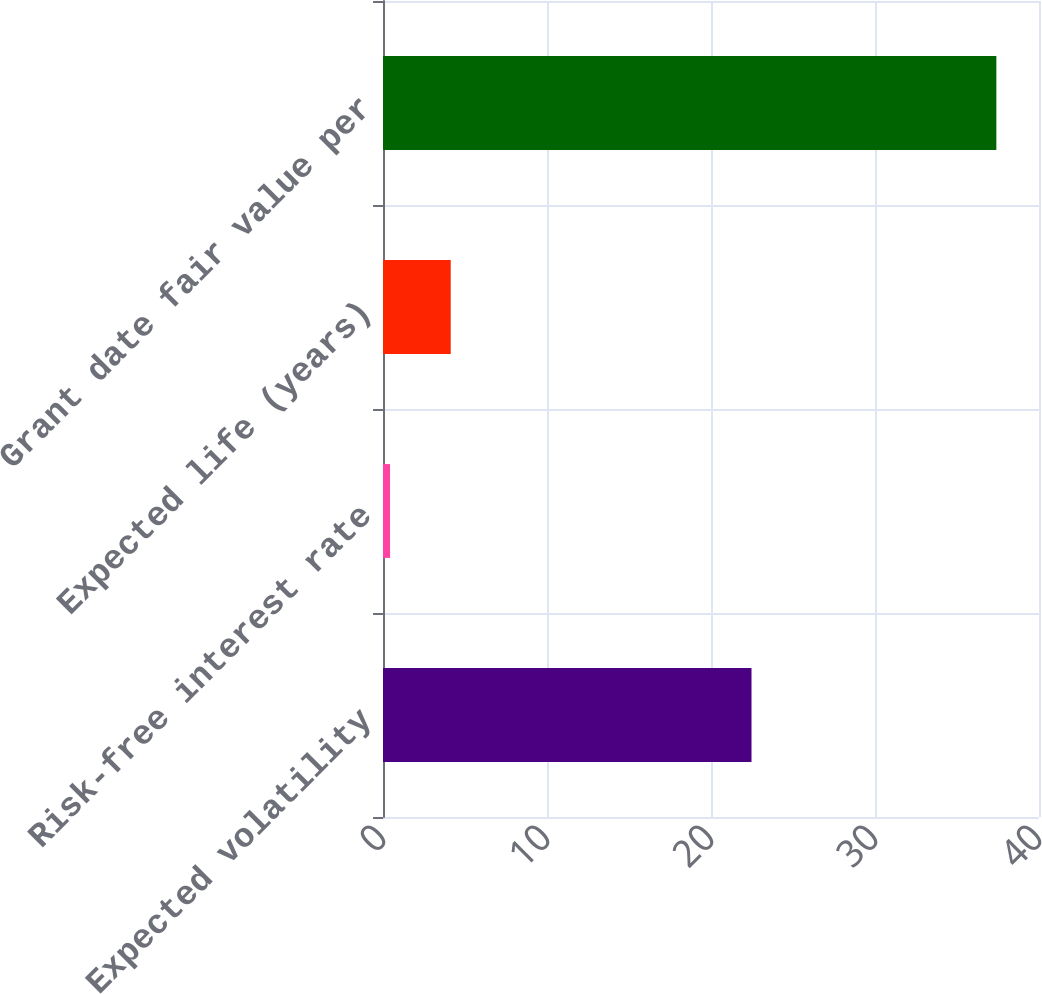Convert chart. <chart><loc_0><loc_0><loc_500><loc_500><bar_chart><fcel>Expected volatility<fcel>Risk-free interest rate<fcel>Expected life (years)<fcel>Grant date fair value per<nl><fcel>22.47<fcel>0.43<fcel>4.13<fcel>37.4<nl></chart> 